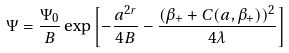Convert formula to latex. <formula><loc_0><loc_0><loc_500><loc_500>\Psi = \frac { \Psi _ { 0 } } { B } \exp \left [ - \frac { a ^ { 2 r } } { 4 B } - \frac { ( \beta _ { + } + C ( a , \beta _ { + } ) ) ^ { 2 } } { 4 \lambda } \right ]</formula> 